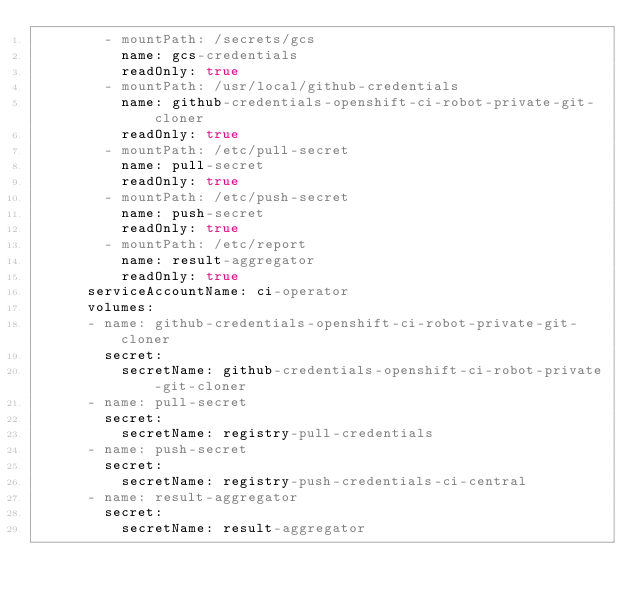Convert code to text. <code><loc_0><loc_0><loc_500><loc_500><_YAML_>        - mountPath: /secrets/gcs
          name: gcs-credentials
          readOnly: true
        - mountPath: /usr/local/github-credentials
          name: github-credentials-openshift-ci-robot-private-git-cloner
          readOnly: true
        - mountPath: /etc/pull-secret
          name: pull-secret
          readOnly: true
        - mountPath: /etc/push-secret
          name: push-secret
          readOnly: true
        - mountPath: /etc/report
          name: result-aggregator
          readOnly: true
      serviceAccountName: ci-operator
      volumes:
      - name: github-credentials-openshift-ci-robot-private-git-cloner
        secret:
          secretName: github-credentials-openshift-ci-robot-private-git-cloner
      - name: pull-secret
        secret:
          secretName: registry-pull-credentials
      - name: push-secret
        secret:
          secretName: registry-push-credentials-ci-central
      - name: result-aggregator
        secret:
          secretName: result-aggregator
</code> 